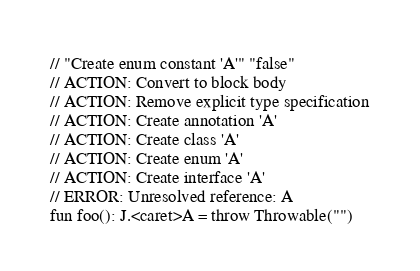<code> <loc_0><loc_0><loc_500><loc_500><_Kotlin_>// "Create enum constant 'A'" "false"
// ACTION: Convert to block body
// ACTION: Remove explicit type specification
// ACTION: Create annotation 'A'
// ACTION: Create class 'A'
// ACTION: Create enum 'A'
// ACTION: Create interface 'A'
// ERROR: Unresolved reference: A
fun foo(): J.<caret>A = throw Throwable("")</code> 